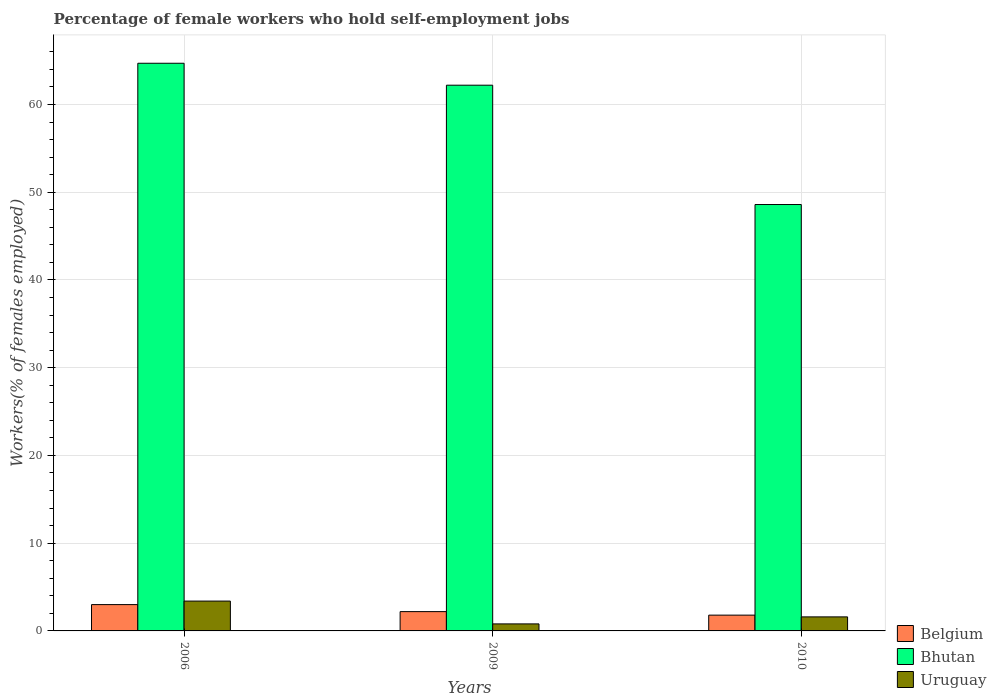How many different coloured bars are there?
Provide a short and direct response. 3. How many groups of bars are there?
Your response must be concise. 3. Are the number of bars on each tick of the X-axis equal?
Make the answer very short. Yes. How many bars are there on the 1st tick from the right?
Your response must be concise. 3. What is the label of the 3rd group of bars from the left?
Make the answer very short. 2010. In how many cases, is the number of bars for a given year not equal to the number of legend labels?
Offer a very short reply. 0. What is the percentage of self-employed female workers in Belgium in 2006?
Offer a terse response. 3. Across all years, what is the maximum percentage of self-employed female workers in Uruguay?
Your response must be concise. 3.4. Across all years, what is the minimum percentage of self-employed female workers in Uruguay?
Your answer should be very brief. 0.8. What is the total percentage of self-employed female workers in Uruguay in the graph?
Give a very brief answer. 5.8. What is the difference between the percentage of self-employed female workers in Belgium in 2006 and that in 2010?
Make the answer very short. 1.2. What is the difference between the percentage of self-employed female workers in Uruguay in 2010 and the percentage of self-employed female workers in Belgium in 2006?
Keep it short and to the point. -1.4. What is the average percentage of self-employed female workers in Belgium per year?
Provide a short and direct response. 2.33. In the year 2006, what is the difference between the percentage of self-employed female workers in Uruguay and percentage of self-employed female workers in Belgium?
Keep it short and to the point. 0.4. What is the ratio of the percentage of self-employed female workers in Belgium in 2006 to that in 2009?
Your response must be concise. 1.36. Is the percentage of self-employed female workers in Uruguay in 2006 less than that in 2009?
Offer a terse response. No. What is the difference between the highest and the second highest percentage of self-employed female workers in Uruguay?
Offer a very short reply. 1.8. What is the difference between the highest and the lowest percentage of self-employed female workers in Bhutan?
Your response must be concise. 16.1. What does the 2nd bar from the left in 2006 represents?
Your answer should be compact. Bhutan. How many years are there in the graph?
Make the answer very short. 3. Are the values on the major ticks of Y-axis written in scientific E-notation?
Provide a succinct answer. No. Where does the legend appear in the graph?
Make the answer very short. Bottom right. How are the legend labels stacked?
Ensure brevity in your answer.  Vertical. What is the title of the graph?
Offer a terse response. Percentage of female workers who hold self-employment jobs. Does "Panama" appear as one of the legend labels in the graph?
Provide a short and direct response. No. What is the label or title of the X-axis?
Give a very brief answer. Years. What is the label or title of the Y-axis?
Your response must be concise. Workers(% of females employed). What is the Workers(% of females employed) of Belgium in 2006?
Offer a terse response. 3. What is the Workers(% of females employed) in Bhutan in 2006?
Provide a succinct answer. 64.7. What is the Workers(% of females employed) in Uruguay in 2006?
Offer a very short reply. 3.4. What is the Workers(% of females employed) of Belgium in 2009?
Keep it short and to the point. 2.2. What is the Workers(% of females employed) of Bhutan in 2009?
Your answer should be very brief. 62.2. What is the Workers(% of females employed) in Uruguay in 2009?
Your response must be concise. 0.8. What is the Workers(% of females employed) in Belgium in 2010?
Your response must be concise. 1.8. What is the Workers(% of females employed) in Bhutan in 2010?
Offer a very short reply. 48.6. What is the Workers(% of females employed) in Uruguay in 2010?
Offer a very short reply. 1.6. Across all years, what is the maximum Workers(% of females employed) in Belgium?
Your response must be concise. 3. Across all years, what is the maximum Workers(% of females employed) of Bhutan?
Provide a succinct answer. 64.7. Across all years, what is the maximum Workers(% of females employed) in Uruguay?
Provide a succinct answer. 3.4. Across all years, what is the minimum Workers(% of females employed) of Belgium?
Your answer should be very brief. 1.8. Across all years, what is the minimum Workers(% of females employed) in Bhutan?
Your answer should be compact. 48.6. Across all years, what is the minimum Workers(% of females employed) in Uruguay?
Provide a succinct answer. 0.8. What is the total Workers(% of females employed) of Bhutan in the graph?
Offer a terse response. 175.5. What is the difference between the Workers(% of females employed) in Bhutan in 2006 and that in 2009?
Offer a very short reply. 2.5. What is the difference between the Workers(% of females employed) of Belgium in 2009 and that in 2010?
Provide a succinct answer. 0.4. What is the difference between the Workers(% of females employed) of Bhutan in 2009 and that in 2010?
Provide a short and direct response. 13.6. What is the difference between the Workers(% of females employed) in Uruguay in 2009 and that in 2010?
Keep it short and to the point. -0.8. What is the difference between the Workers(% of females employed) in Belgium in 2006 and the Workers(% of females employed) in Bhutan in 2009?
Your response must be concise. -59.2. What is the difference between the Workers(% of females employed) in Belgium in 2006 and the Workers(% of females employed) in Uruguay in 2009?
Your answer should be compact. 2.2. What is the difference between the Workers(% of females employed) in Bhutan in 2006 and the Workers(% of females employed) in Uruguay in 2009?
Give a very brief answer. 63.9. What is the difference between the Workers(% of females employed) of Belgium in 2006 and the Workers(% of females employed) of Bhutan in 2010?
Provide a succinct answer. -45.6. What is the difference between the Workers(% of females employed) of Belgium in 2006 and the Workers(% of females employed) of Uruguay in 2010?
Give a very brief answer. 1.4. What is the difference between the Workers(% of females employed) in Bhutan in 2006 and the Workers(% of females employed) in Uruguay in 2010?
Provide a succinct answer. 63.1. What is the difference between the Workers(% of females employed) in Belgium in 2009 and the Workers(% of females employed) in Bhutan in 2010?
Your response must be concise. -46.4. What is the difference between the Workers(% of females employed) in Bhutan in 2009 and the Workers(% of females employed) in Uruguay in 2010?
Make the answer very short. 60.6. What is the average Workers(% of females employed) in Belgium per year?
Your response must be concise. 2.33. What is the average Workers(% of females employed) of Bhutan per year?
Your answer should be compact. 58.5. What is the average Workers(% of females employed) in Uruguay per year?
Your answer should be compact. 1.93. In the year 2006, what is the difference between the Workers(% of females employed) of Belgium and Workers(% of females employed) of Bhutan?
Your response must be concise. -61.7. In the year 2006, what is the difference between the Workers(% of females employed) in Bhutan and Workers(% of females employed) in Uruguay?
Offer a terse response. 61.3. In the year 2009, what is the difference between the Workers(% of females employed) in Belgium and Workers(% of females employed) in Bhutan?
Ensure brevity in your answer.  -60. In the year 2009, what is the difference between the Workers(% of females employed) of Belgium and Workers(% of females employed) of Uruguay?
Provide a short and direct response. 1.4. In the year 2009, what is the difference between the Workers(% of females employed) of Bhutan and Workers(% of females employed) of Uruguay?
Give a very brief answer. 61.4. In the year 2010, what is the difference between the Workers(% of females employed) of Belgium and Workers(% of females employed) of Bhutan?
Keep it short and to the point. -46.8. What is the ratio of the Workers(% of females employed) of Belgium in 2006 to that in 2009?
Your response must be concise. 1.36. What is the ratio of the Workers(% of females employed) in Bhutan in 2006 to that in 2009?
Keep it short and to the point. 1.04. What is the ratio of the Workers(% of females employed) of Uruguay in 2006 to that in 2009?
Keep it short and to the point. 4.25. What is the ratio of the Workers(% of females employed) in Belgium in 2006 to that in 2010?
Provide a short and direct response. 1.67. What is the ratio of the Workers(% of females employed) of Bhutan in 2006 to that in 2010?
Provide a short and direct response. 1.33. What is the ratio of the Workers(% of females employed) in Uruguay in 2006 to that in 2010?
Your response must be concise. 2.12. What is the ratio of the Workers(% of females employed) of Belgium in 2009 to that in 2010?
Keep it short and to the point. 1.22. What is the ratio of the Workers(% of females employed) in Bhutan in 2009 to that in 2010?
Your answer should be very brief. 1.28. What is the ratio of the Workers(% of females employed) of Uruguay in 2009 to that in 2010?
Your response must be concise. 0.5. What is the difference between the highest and the second highest Workers(% of females employed) of Belgium?
Your response must be concise. 0.8. What is the difference between the highest and the lowest Workers(% of females employed) in Uruguay?
Offer a very short reply. 2.6. 